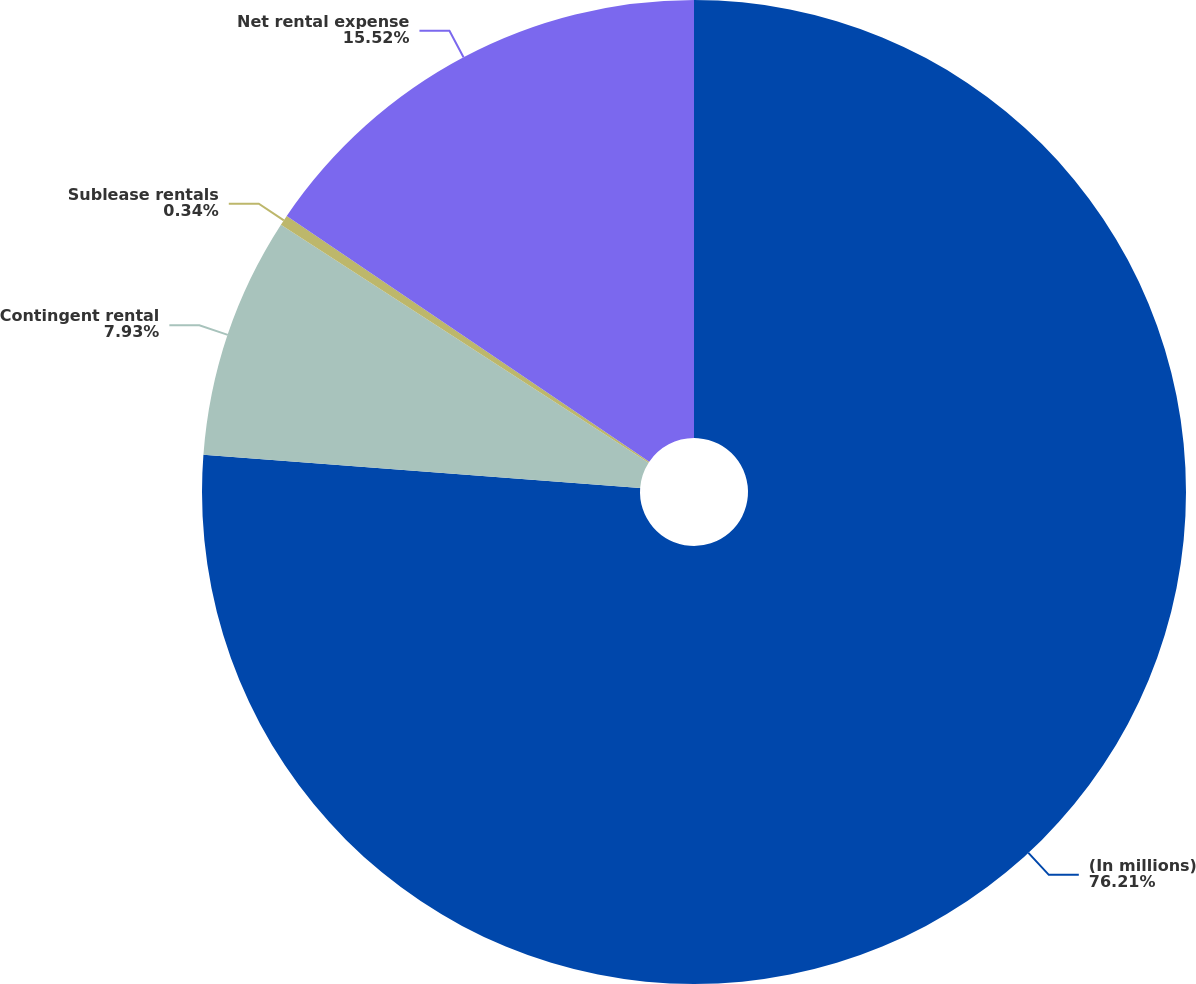<chart> <loc_0><loc_0><loc_500><loc_500><pie_chart><fcel>(In millions)<fcel>Contingent rental<fcel>Sublease rentals<fcel>Net rental expense<nl><fcel>76.21%<fcel>7.93%<fcel>0.34%<fcel>15.52%<nl></chart> 